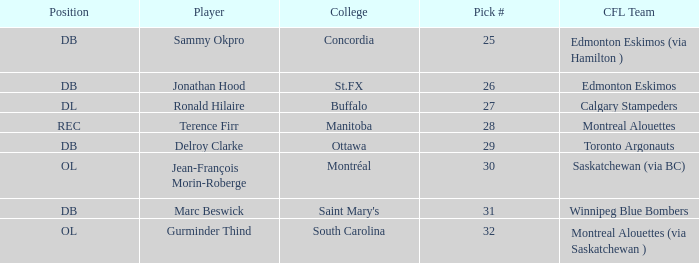Which College has a Position of ol, and a Pick # smaller than 32? Montréal. 